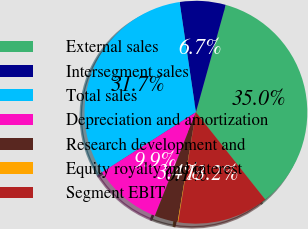Convert chart. <chart><loc_0><loc_0><loc_500><loc_500><pie_chart><fcel>External sales<fcel>Intersegment sales<fcel>Total sales<fcel>Depreciation and amortization<fcel>Research development and<fcel>Equity royalty and interest<fcel>Segment EBIT<nl><fcel>35.01%<fcel>6.65%<fcel>31.73%<fcel>9.93%<fcel>3.37%<fcel>0.1%<fcel>13.21%<nl></chart> 